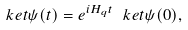Convert formula to latex. <formula><loc_0><loc_0><loc_500><loc_500>\ k e t { \psi ( t ) } = e ^ { i H _ { q } t } \ k e t { \psi ( 0 ) } ,</formula> 